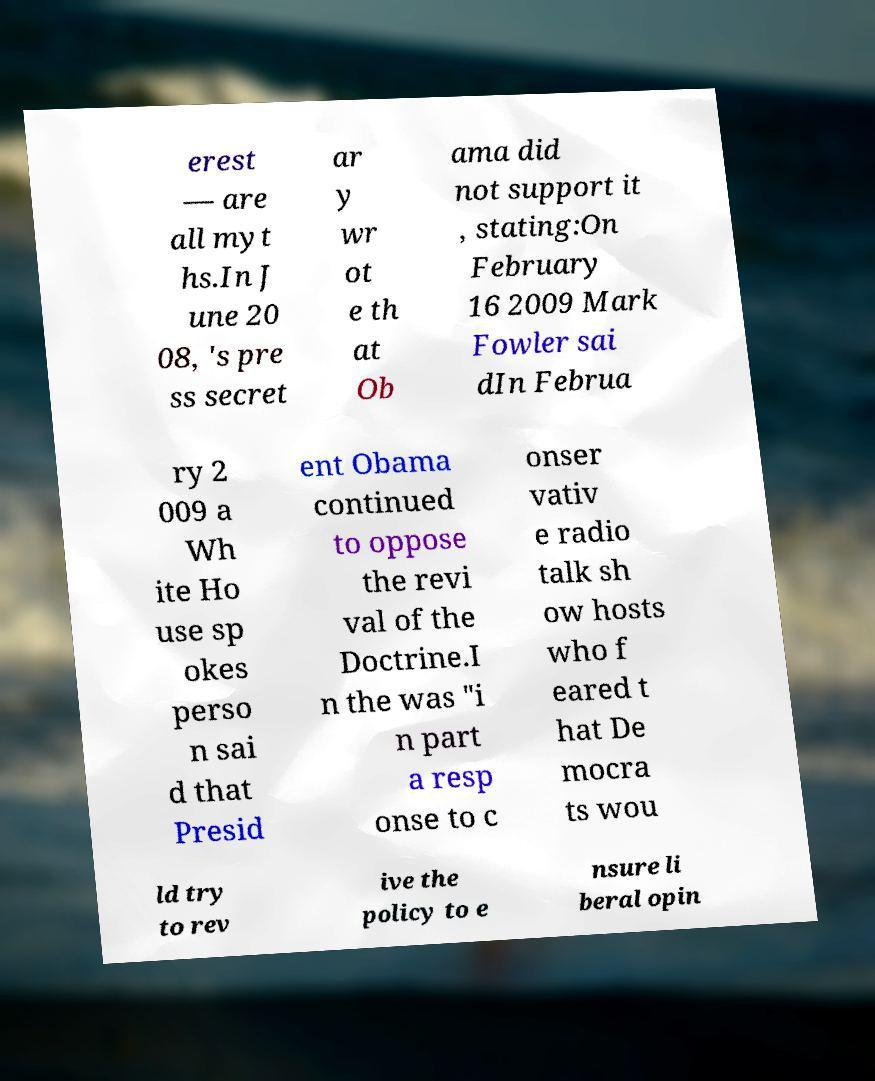I need the written content from this picture converted into text. Can you do that? erest — are all myt hs.In J une 20 08, 's pre ss secret ar y wr ot e th at Ob ama did not support it , stating:On February 16 2009 Mark Fowler sai dIn Februa ry 2 009 a Wh ite Ho use sp okes perso n sai d that Presid ent Obama continued to oppose the revi val of the Doctrine.I n the was "i n part a resp onse to c onser vativ e radio talk sh ow hosts who f eared t hat De mocra ts wou ld try to rev ive the policy to e nsure li beral opin 